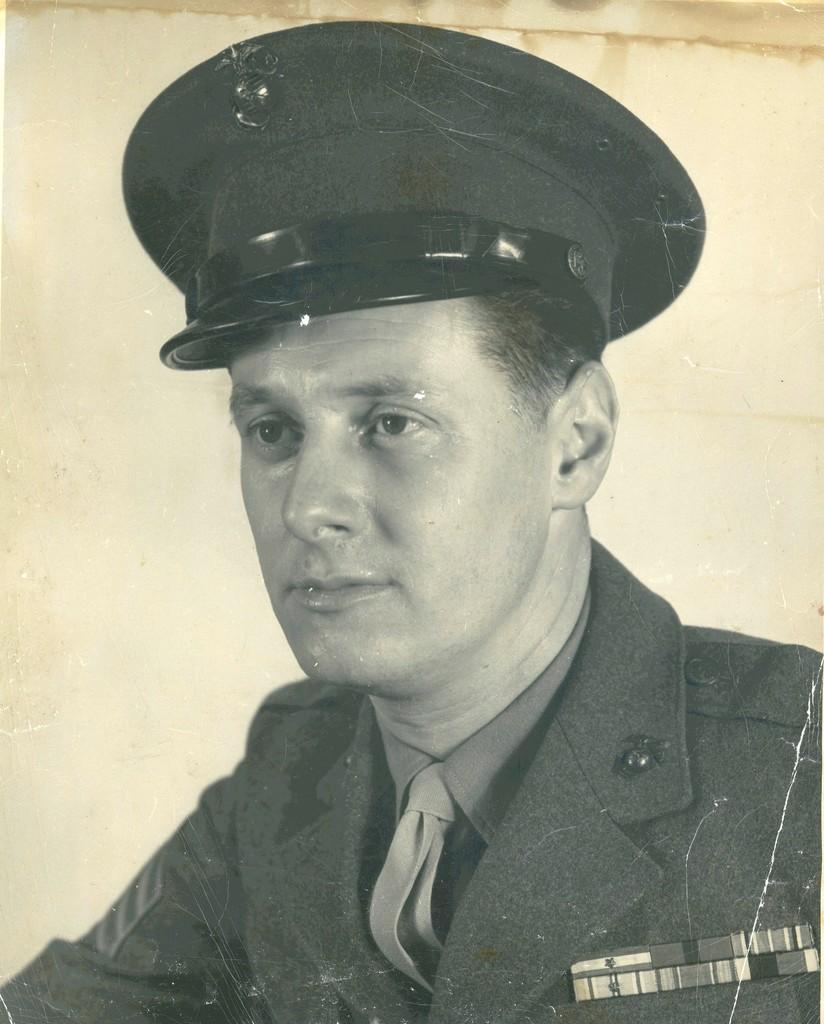Who is present in the image? There is a man in the image. What is the man wearing on his head? The man is wearing a cap. In which direction is the man looking? The man is looking to the left. What can be seen on the man's court? There is a badge on the man's court. What is visible in the background of the image? There is a wall in the background of the image. What disease is the man trying to cure in the image? There is no indication of a disease or any medical context in the image. The man is simply wearing a cap and looking to the left. 